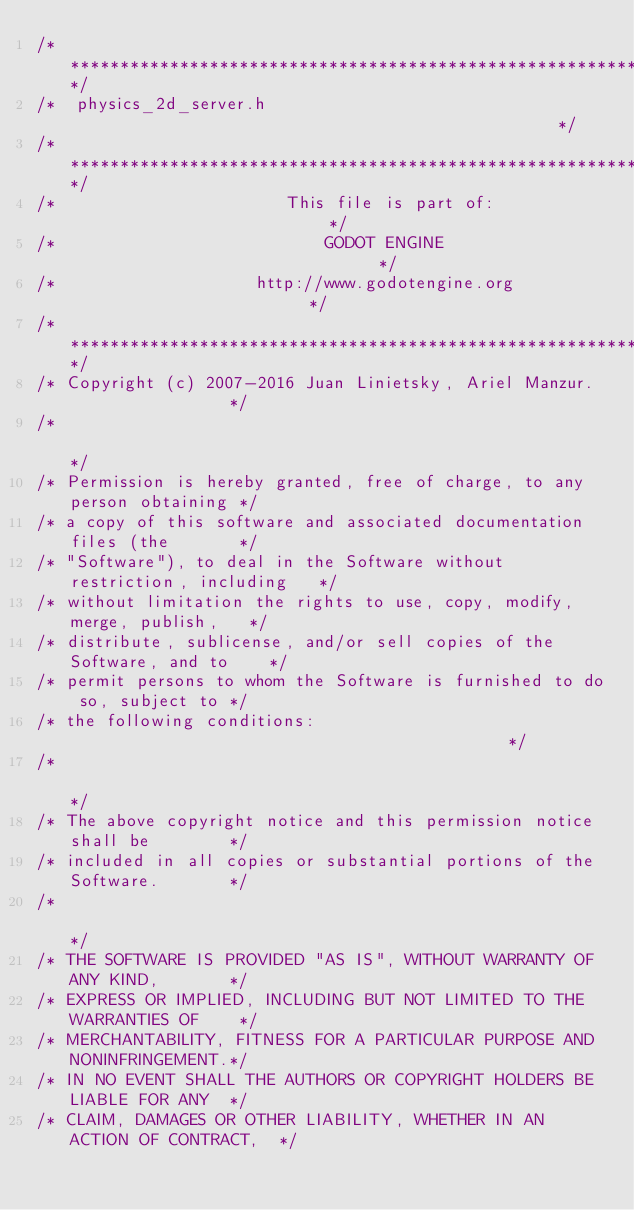<code> <loc_0><loc_0><loc_500><loc_500><_C_>/*************************************************************************/
/*  physics_2d_server.h                                                  */
/*************************************************************************/
/*                       This file is part of:                           */
/*                           GODOT ENGINE                                */
/*                    http://www.godotengine.org                         */
/*************************************************************************/
/* Copyright (c) 2007-2016 Juan Linietsky, Ariel Manzur.                 */
/*                                                                       */
/* Permission is hereby granted, free of charge, to any person obtaining */
/* a copy of this software and associated documentation files (the       */
/* "Software"), to deal in the Software without restriction, including   */
/* without limitation the rights to use, copy, modify, merge, publish,   */
/* distribute, sublicense, and/or sell copies of the Software, and to    */
/* permit persons to whom the Software is furnished to do so, subject to */
/* the following conditions:                                             */
/*                                                                       */
/* The above copyright notice and this permission notice shall be        */
/* included in all copies or substantial portions of the Software.       */
/*                                                                       */
/* THE SOFTWARE IS PROVIDED "AS IS", WITHOUT WARRANTY OF ANY KIND,       */
/* EXPRESS OR IMPLIED, INCLUDING BUT NOT LIMITED TO THE WARRANTIES OF    */
/* MERCHANTABILITY, FITNESS FOR A PARTICULAR PURPOSE AND NONINFRINGEMENT.*/
/* IN NO EVENT SHALL THE AUTHORS OR COPYRIGHT HOLDERS BE LIABLE FOR ANY  */
/* CLAIM, DAMAGES OR OTHER LIABILITY, WHETHER IN AN ACTION OF CONTRACT,  */</code> 